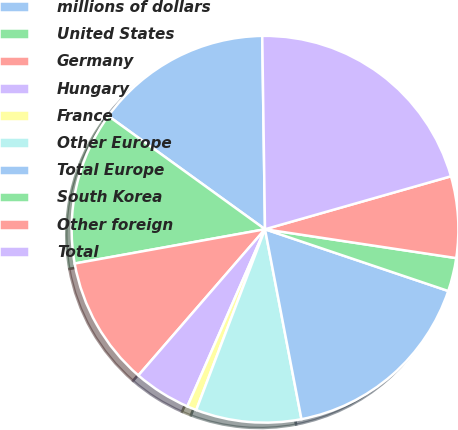<chart> <loc_0><loc_0><loc_500><loc_500><pie_chart><fcel>millions of dollars<fcel>United States<fcel>Germany<fcel>Hungary<fcel>France<fcel>Other Europe<fcel>Total Europe<fcel>South Korea<fcel>Other foreign<fcel>Total<nl><fcel>14.81%<fcel>12.8%<fcel>10.8%<fcel>4.79%<fcel>0.79%<fcel>8.8%<fcel>16.81%<fcel>2.79%<fcel>6.8%<fcel>20.81%<nl></chart> 